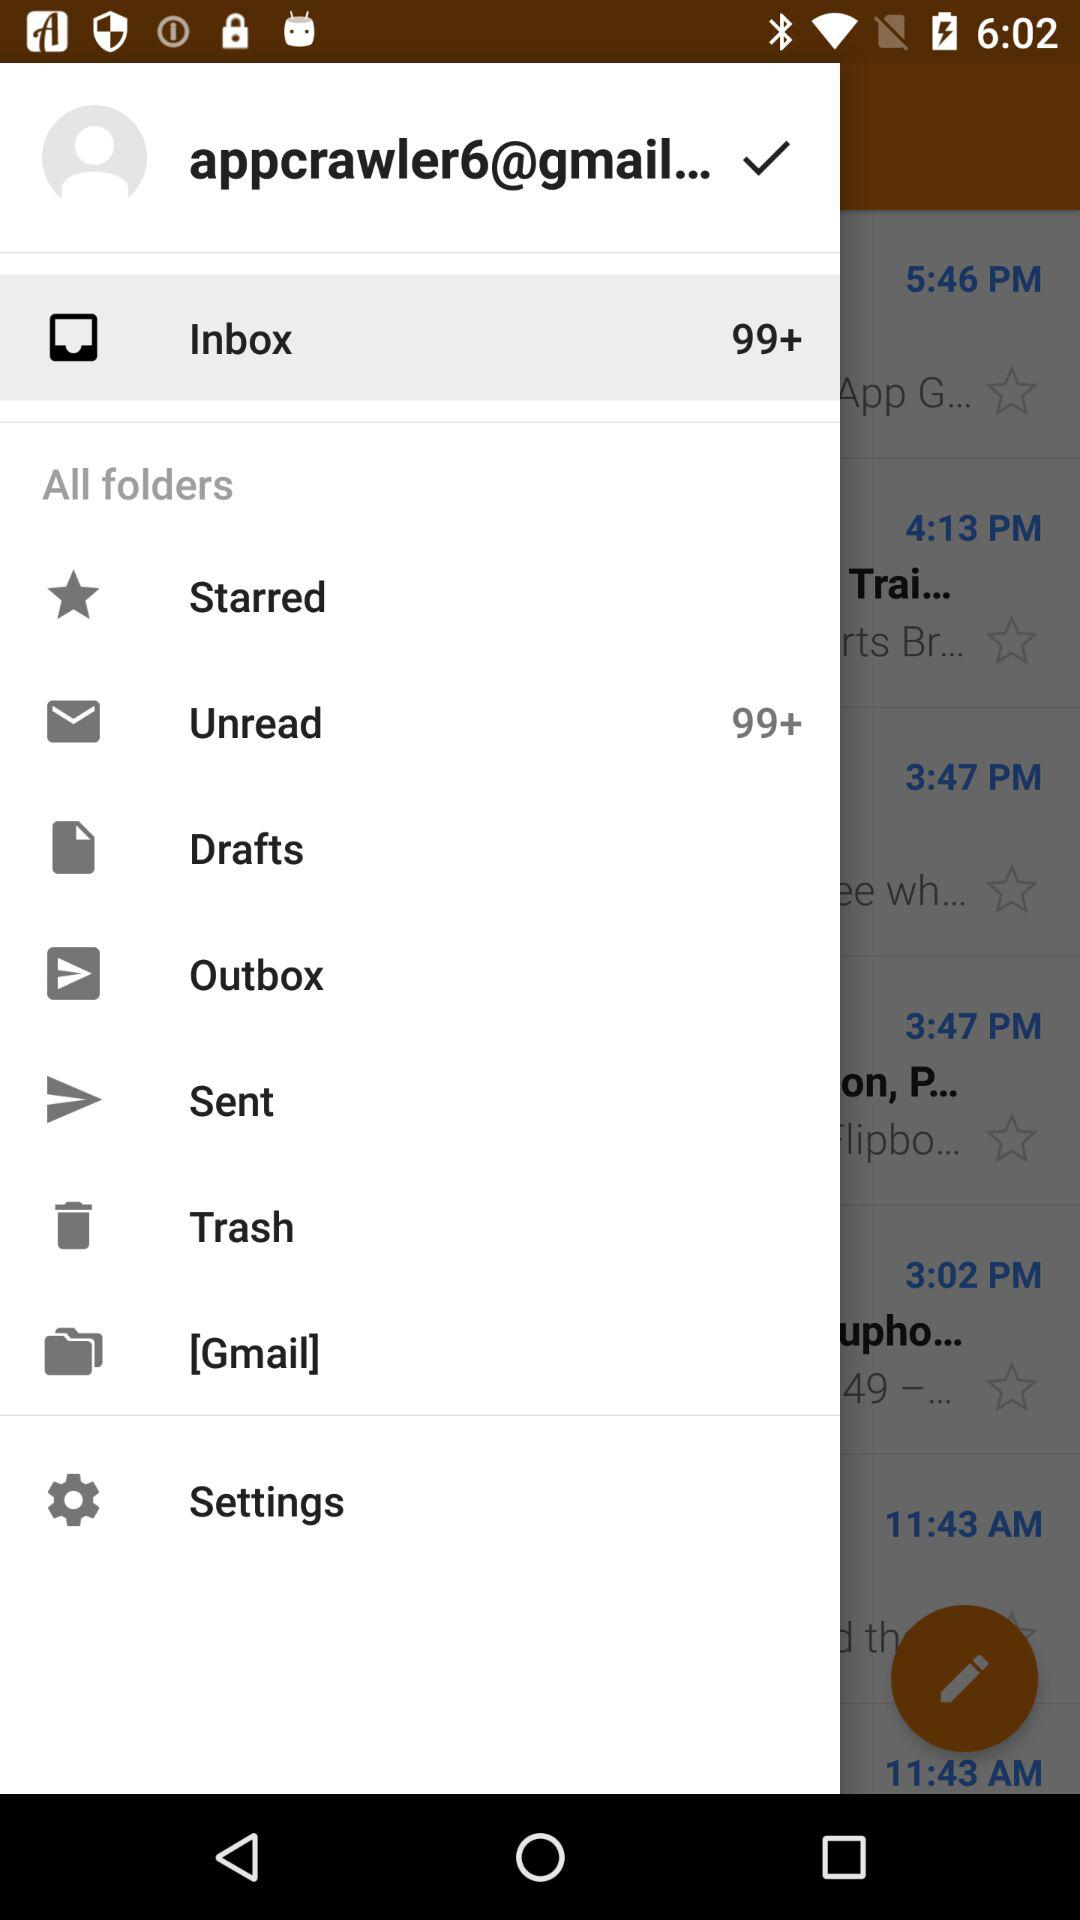How many unread emails are there? There are more than 99 unread emails. 